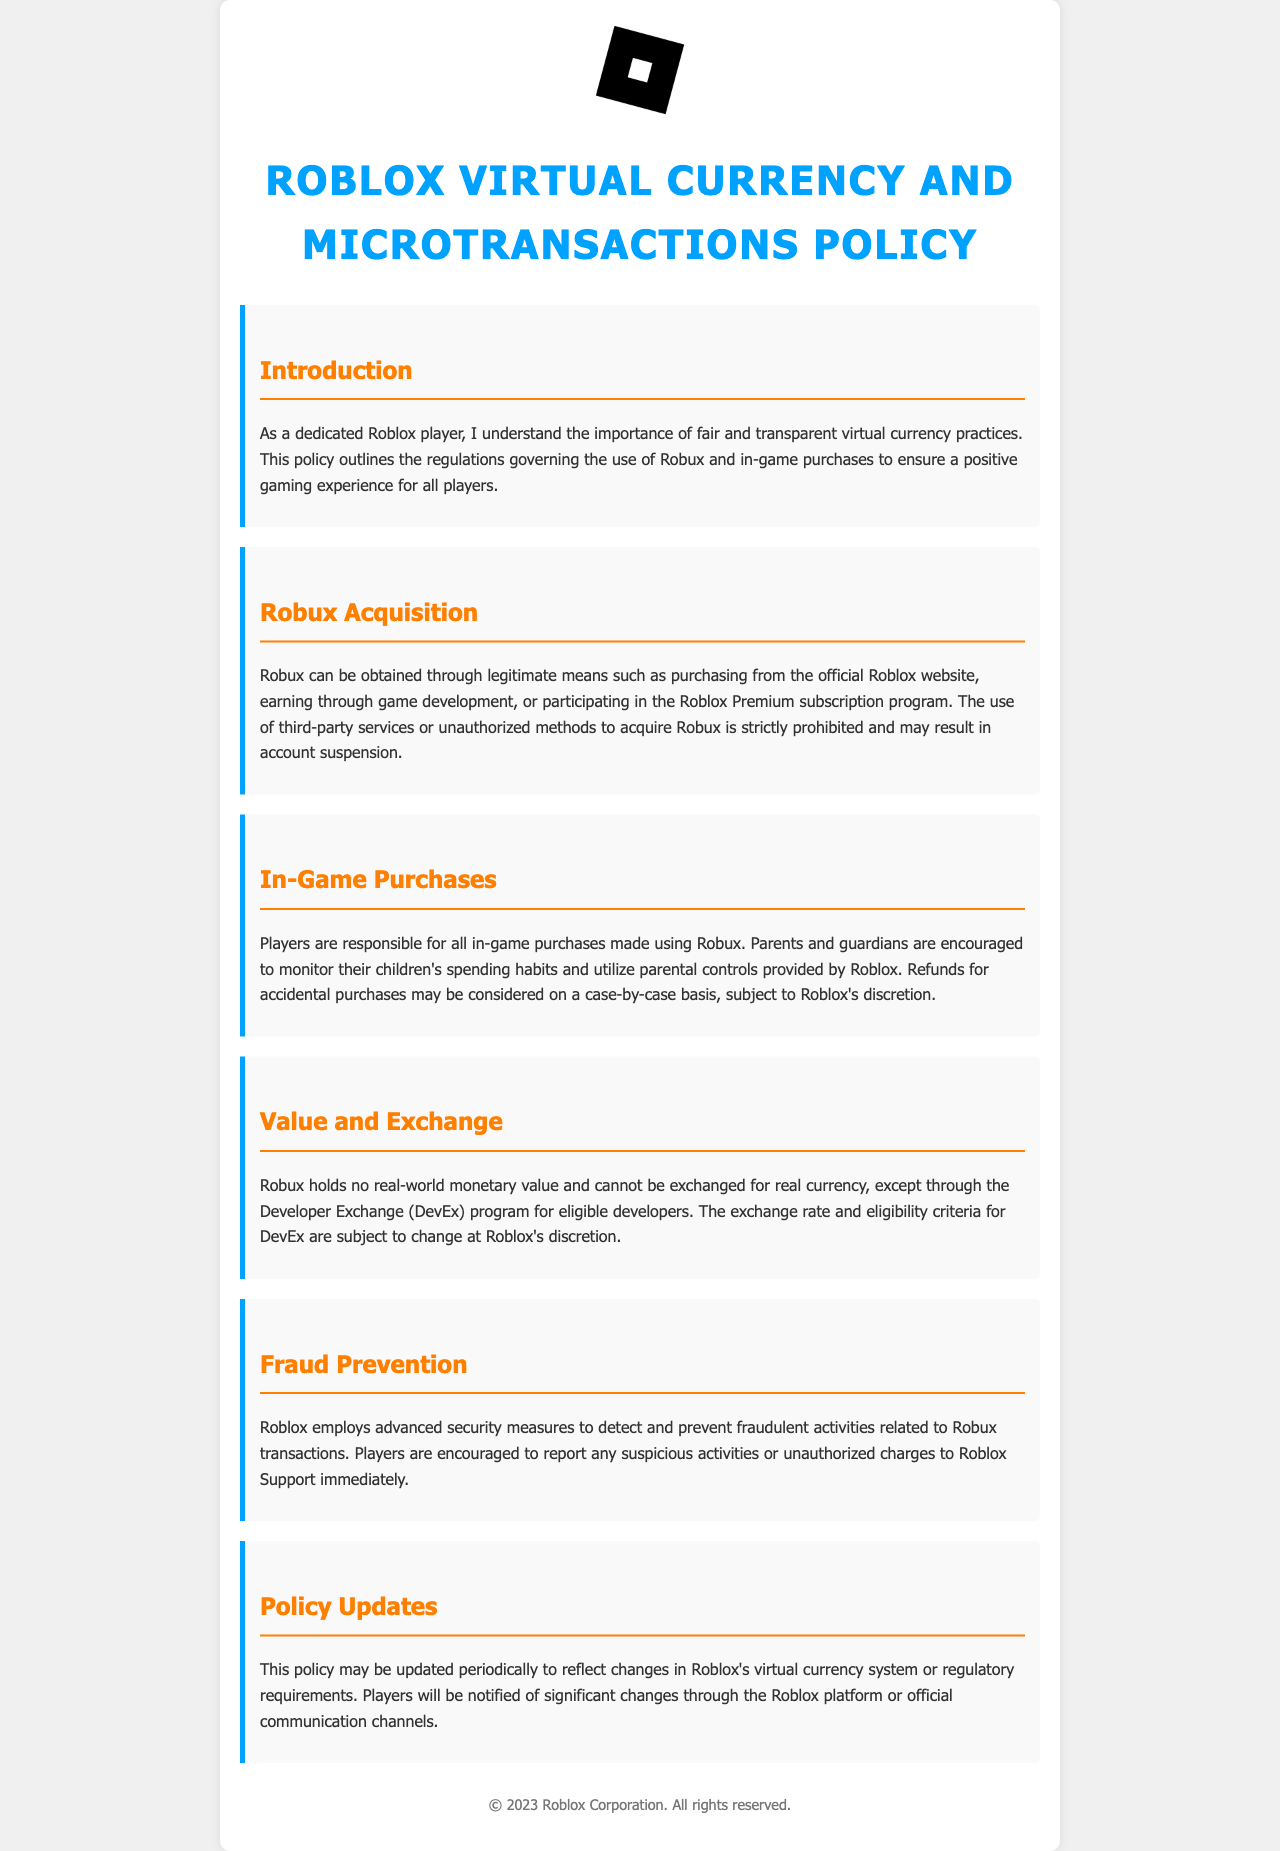What is the title of the document? The title of the document is prominently displayed at the top in large text.
Answer: Roblox Virtual Currency and Microtransactions Policy What can Robux be obtained through? This information is detailed in the section on Robux Acquisition, listing the legitimate ways to obtain Robux.
Answer: Purchasing, earning through game development, Roblox Premium subscription What is the stance on refunds for in-game purchases? Refunds are mentioned in the In-Game Purchases section, indicating the policy on accidental purchases.
Answer: Case-by-case basis What is the value of Robux in real-world currency? The Value and Exchange section explains the status of Robux in relation to real currency.
Answer: No real-world monetary value What should players do in case of suspicious activities? This is outlined in the Fraud Prevention section as recommended actions for players.
Answer: Report to Roblox Support How often may the policy be updated? The Policy Updates section hints at the frequency of updates regarding the policy.
Answer: Periodically 